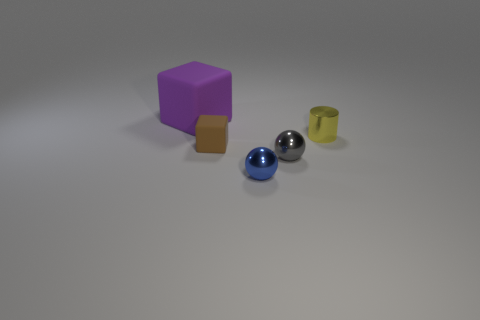Is there anything else that is the same shape as the yellow shiny thing?
Offer a very short reply. No. Are there more tiny brown cubes right of the tiny yellow cylinder than yellow metal blocks?
Your answer should be compact. No. How many other objects are there of the same color as the big rubber cube?
Give a very brief answer. 0. Do the blue metallic thing right of the brown matte thing and the tiny yellow cylinder have the same size?
Offer a very short reply. Yes. Are there any other metallic objects of the same size as the blue metal thing?
Provide a succinct answer. Yes. The small thing in front of the tiny gray thing is what color?
Keep it short and to the point. Blue. There is a object that is both behind the tiny brown rubber thing and in front of the large rubber block; what is its shape?
Your response must be concise. Cylinder. How many tiny blue shiny things have the same shape as the tiny gray thing?
Your answer should be very brief. 1. What number of tiny yellow shiny cylinders are there?
Your answer should be very brief. 1. There is a thing that is both behind the brown cube and on the left side of the metallic cylinder; what is its size?
Provide a succinct answer. Large. 